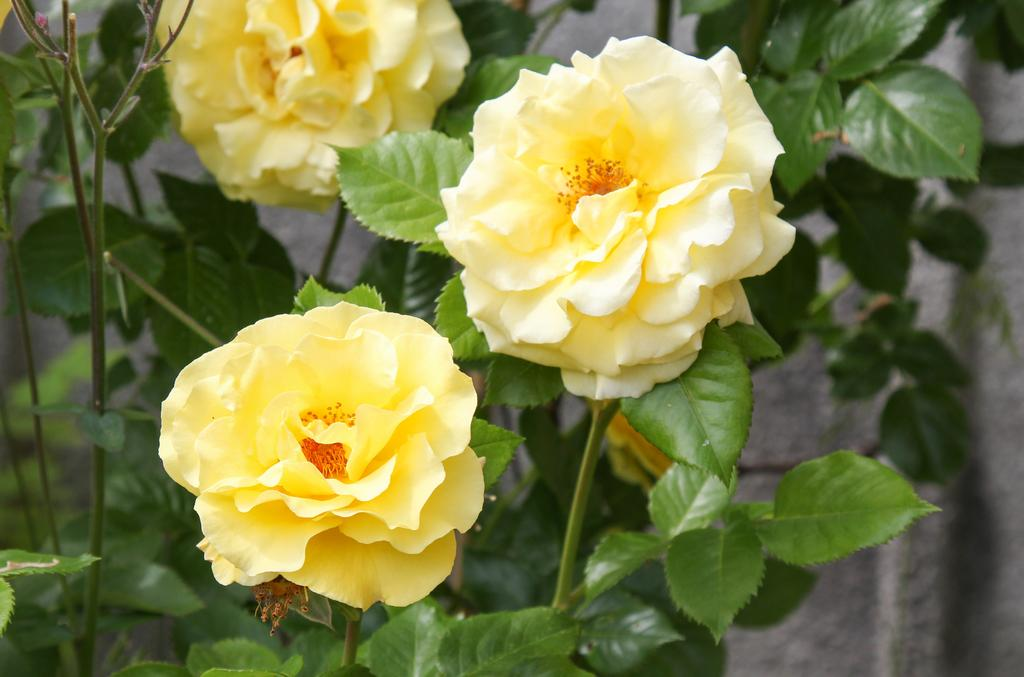What type of living organisms can be seen in the image? Flowers and plants are visible in the image. Can you describe the plants in the image? The image contains flowers, which are a type of plant. What type of string can be seen connecting the flowers in the image? There is no string connecting the flowers in the image. What type of instrument is being played by the flowers in the image? There are no instruments or faces present in the image; it only contains flowers and plants. 